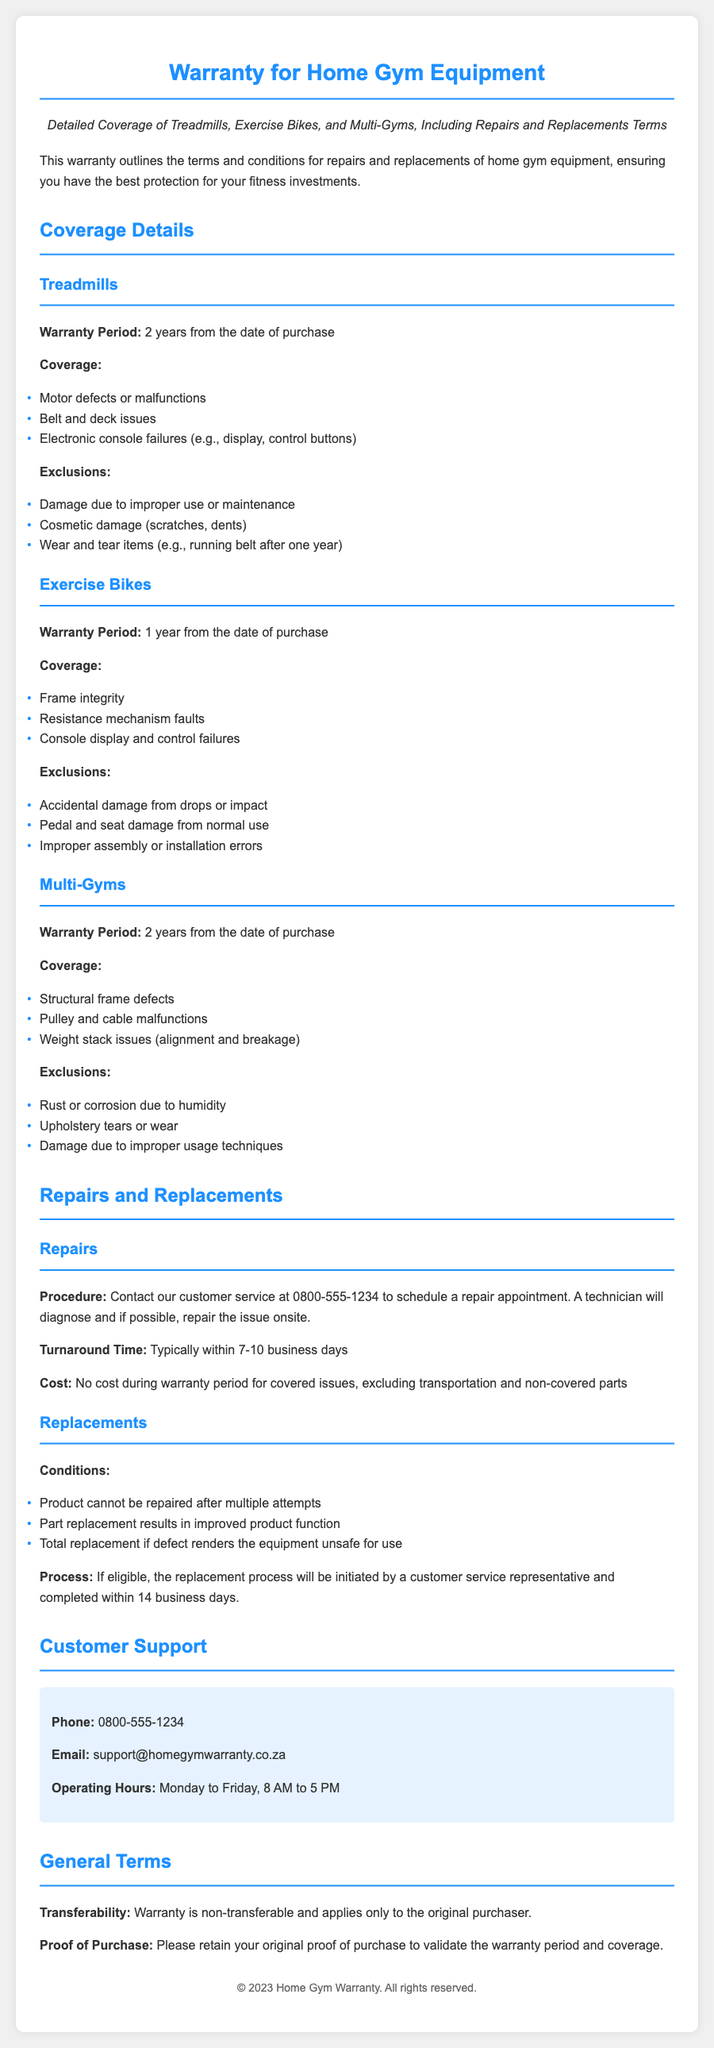What is the warranty period for treadmills? The warranty period for treadmills is specified in the document as 2 years from the date of purchase.
Answer: 2 years What types of defects are covered for exercise bikes? Document mentions that frame integrity, resistance mechanism faults, and console display failures are covered for exercise bikes.
Answer: Frame integrity, resistance mechanism faults, console display failures What items are excluded from treadmill coverage? The document lists exclusions for treadmills such as damage due to improper use, cosmetic damage, and wear and tear items.
Answer: Damage due to improper use, cosmetic damage, wear and tear items How long does the repair turnaround time typically take? The document states that the typical turnaround time for repairs is 7-10 business days.
Answer: 7-10 business days What must be retained to validate the warranty? The document indicates that the original proof of purchase must be retained to validate the warranty period and coverage.
Answer: Original proof of purchase What is the replacement process completion time? The document outlines that the replacement process will be completed within 14 business days if eligible.
Answer: 14 business days What are the operating hours for customer support? The operating hours for customer support are mentioned as Monday to Friday, from 8 AM to 5 PM.
Answer: Monday to Friday, 8 AM to 5 PM Is the warranty transferable? The document explicitly states that the warranty is non-transferable.
Answer: Non-transferable What are the contact methods for customer support? The document provides phone and email information for customer support as methods to contact.
Answer: Phone and email 